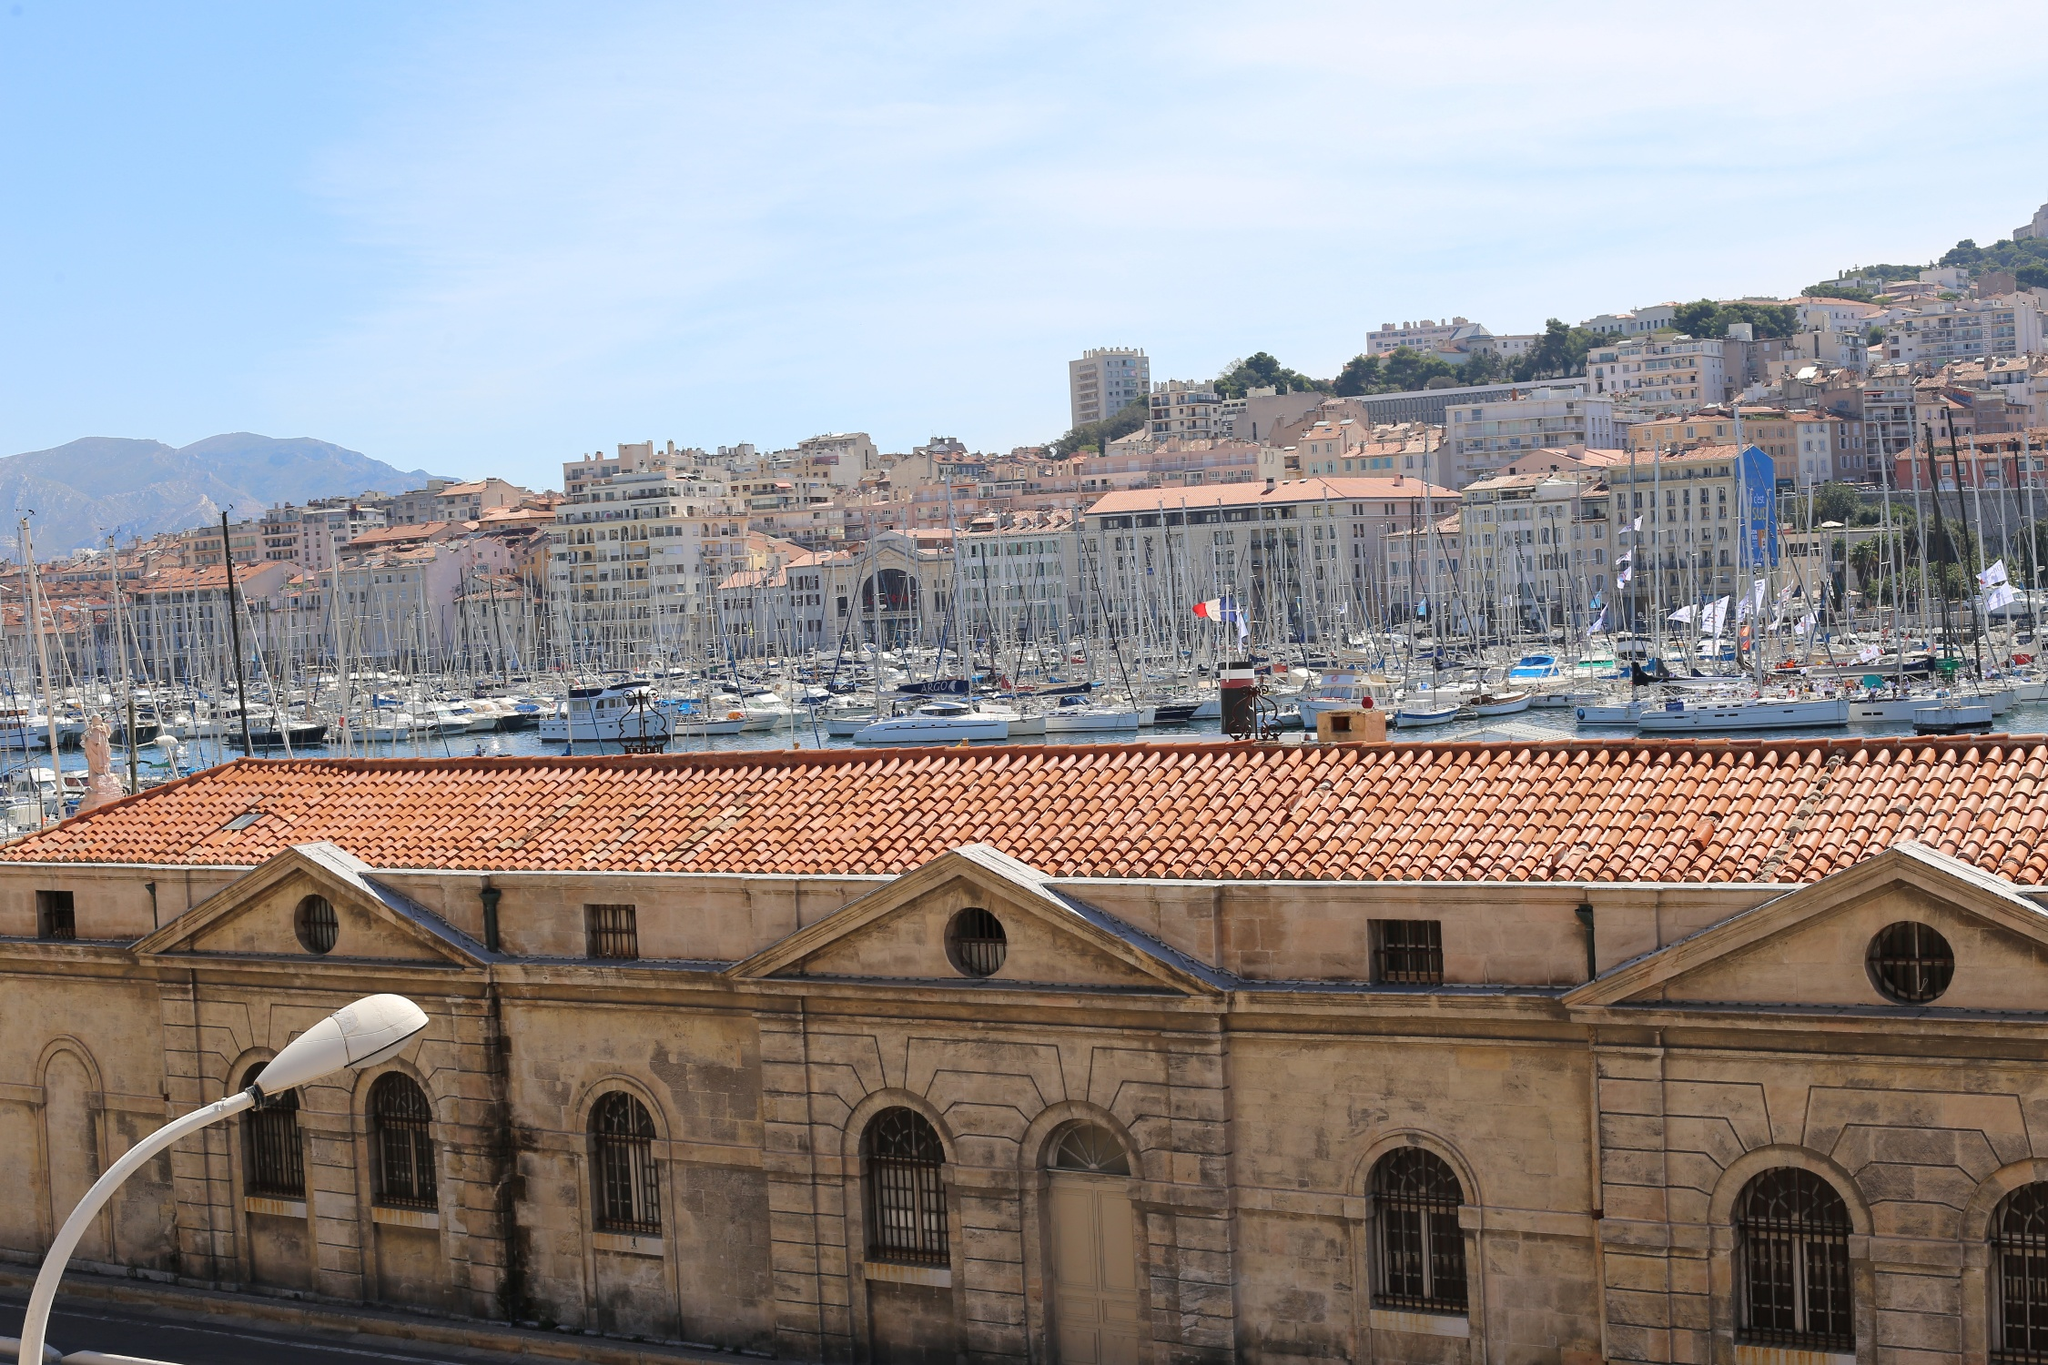Now imagine this image at night. How would the features change and what new elements might appear? At night, the Old Port of Marseille transforms into a magical and serene scene. The waterfront would be elegantly illuminated, with the streetlights casting a warm, gentle glow that reflects off the calm waters of the port. The boats and yachts would be adorned with twinkling lights, creating a fairy-tale-like ambiance. The historic buildings, softly lit, stand in stark but beautiful contrast against the night sky, their architectural details even more pronounced. The cityscape in the background would shimmer with the lights of homes and buildings, adding to the vibrancy. The atmosphere would be less bustling but more intimate, with couples and friends enjoying leisurely evening strolls, and the sounds of the city would soften, replaced by the gentle lapping of water against the boats and the occasional distant laughter from a late-night café. 